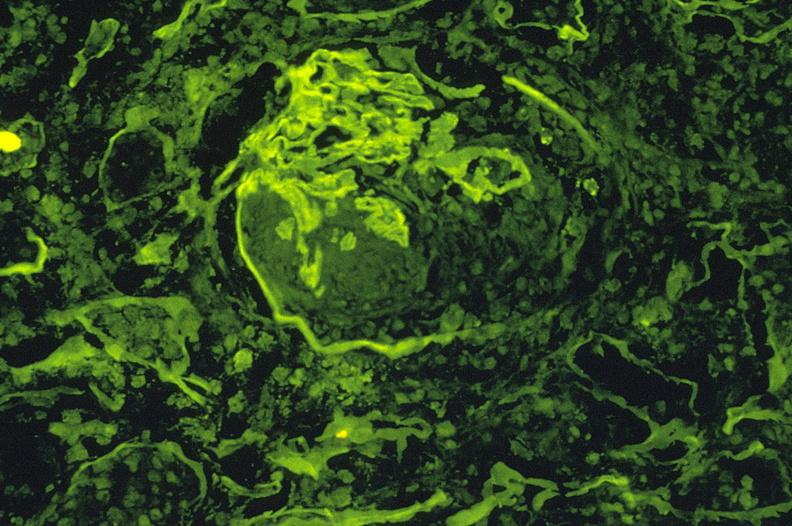where is this?
Answer the question using a single word or phrase. Urinary 